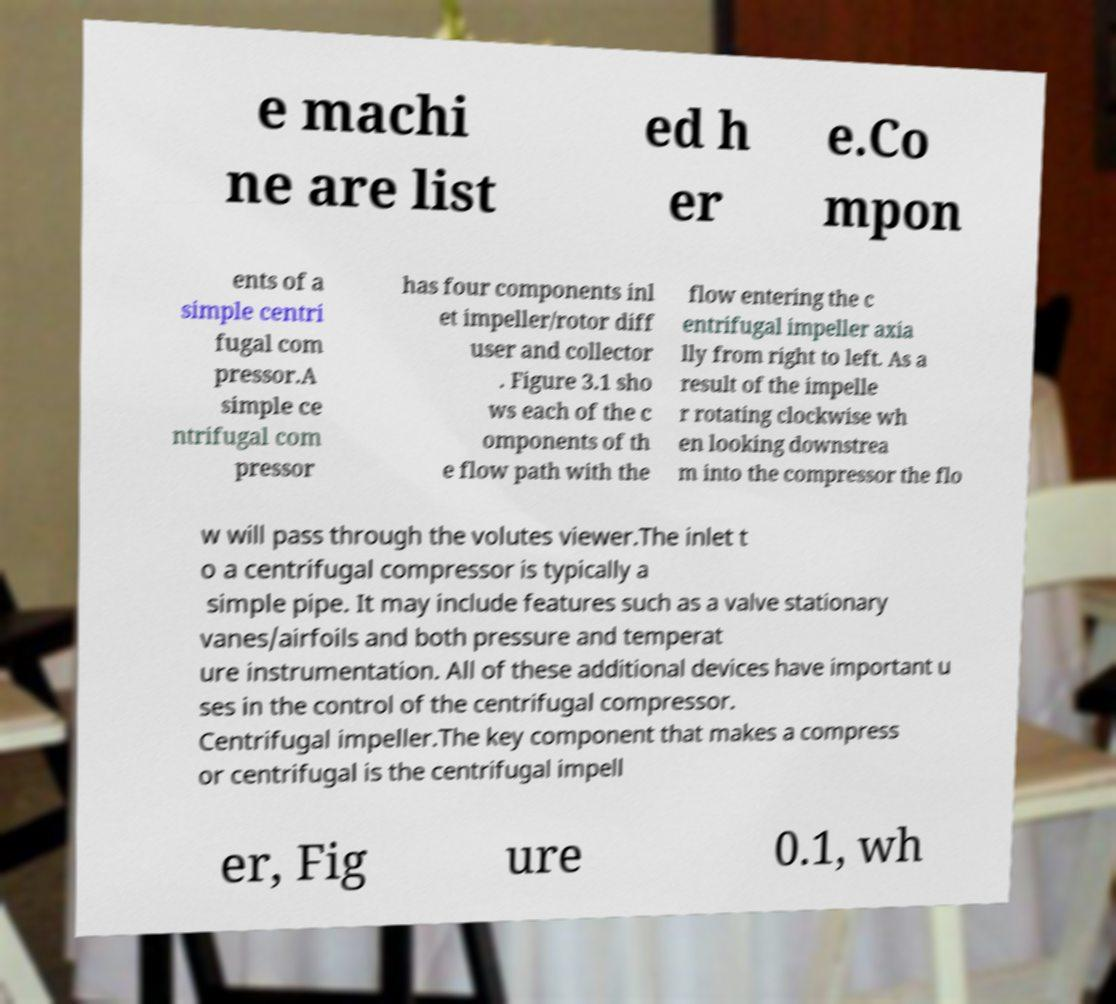Please read and relay the text visible in this image. What does it say? e machi ne are list ed h er e.Co mpon ents of a simple centri fugal com pressor.A simple ce ntrifugal com pressor has four components inl et impeller/rotor diff user and collector . Figure 3.1 sho ws each of the c omponents of th e flow path with the flow entering the c entrifugal impeller axia lly from right to left. As a result of the impelle r rotating clockwise wh en looking downstrea m into the compressor the flo w will pass through the volutes viewer.The inlet t o a centrifugal compressor is typically a simple pipe. It may include features such as a valve stationary vanes/airfoils and both pressure and temperat ure instrumentation. All of these additional devices have important u ses in the control of the centrifugal compressor. Centrifugal impeller.The key component that makes a compress or centrifugal is the centrifugal impell er, Fig ure 0.1, wh 